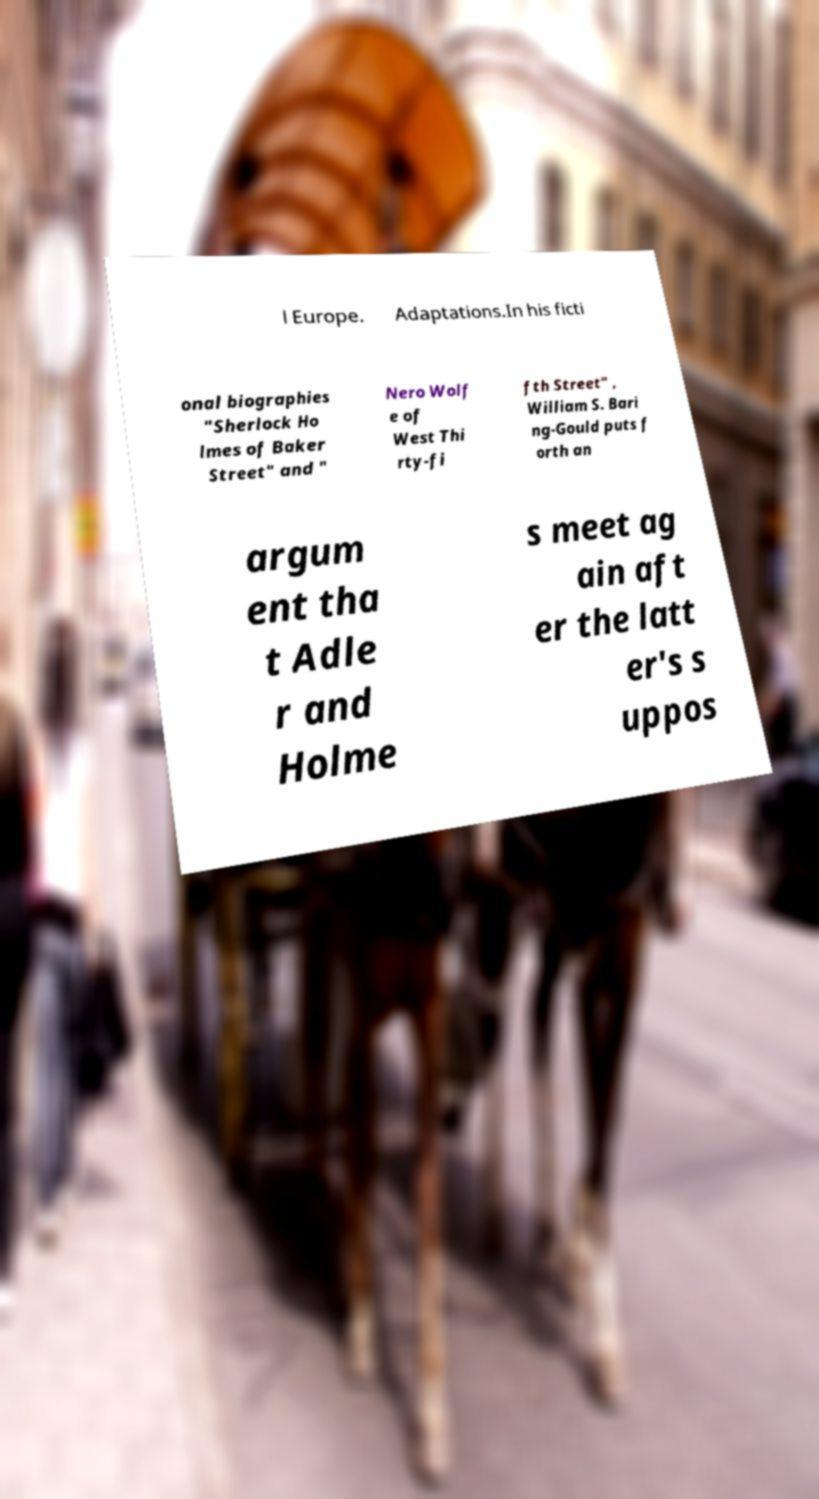Please identify and transcribe the text found in this image. l Europe. Adaptations.In his ficti onal biographies "Sherlock Ho lmes of Baker Street" and " Nero Wolf e of West Thi rty-fi fth Street" , William S. Bari ng-Gould puts f orth an argum ent tha t Adle r and Holme s meet ag ain aft er the latt er's s uppos 